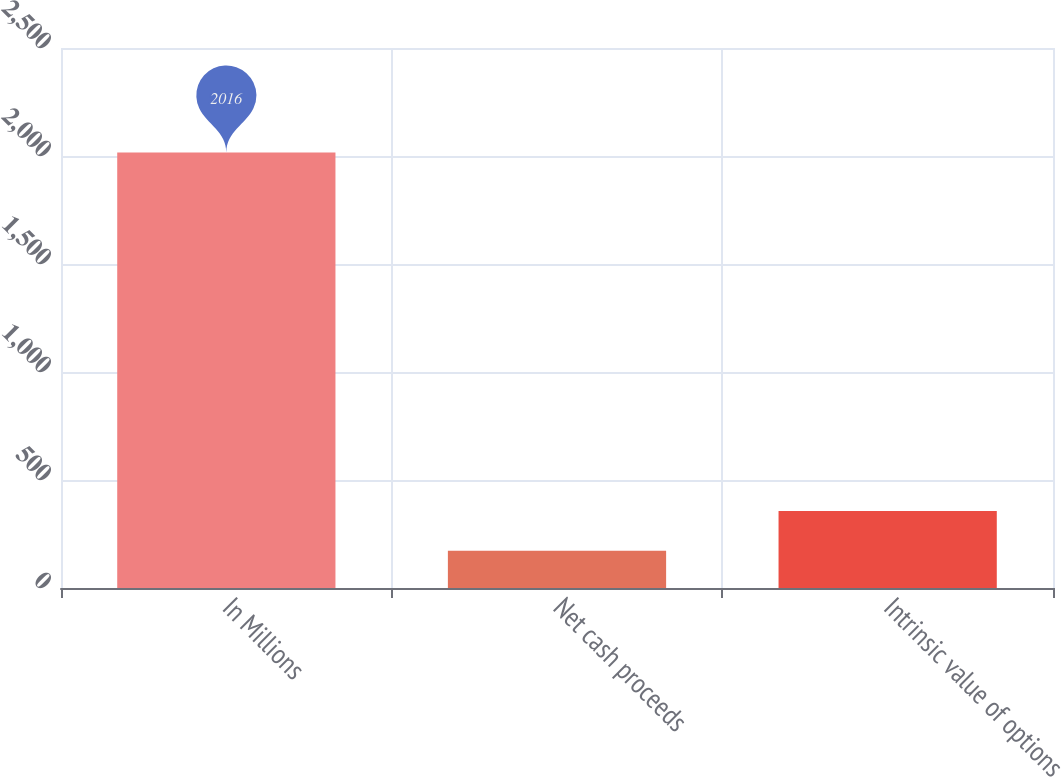<chart> <loc_0><loc_0><loc_500><loc_500><bar_chart><fcel>In Millions<fcel>Net cash proceeds<fcel>Intrinsic value of options<nl><fcel>2016<fcel>171.9<fcel>356.31<nl></chart> 